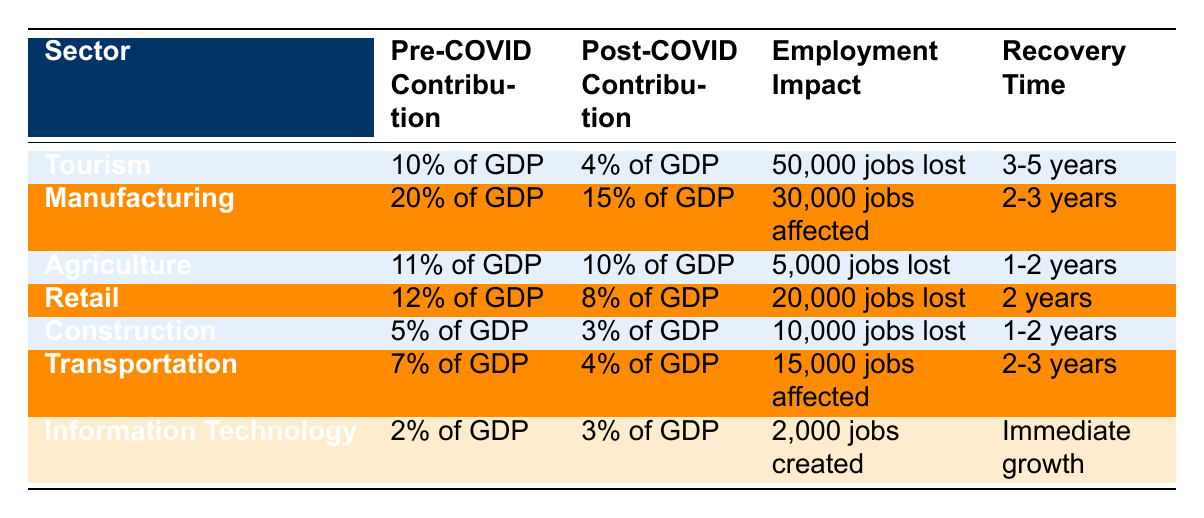What is the post-COVID contribution of the retail sector to GDP? The post-COVID contribution of the retail sector is found in the table, where it is listed as 8% of GDP.
Answer: 8% of GDP How many jobs were lost in the tourism sector due to COVID-19? The table specifies that the tourism sector experienced a loss of 50,000 jobs as a result of COVID-19.
Answer: 50,000 jobs Which sector had the highest pre-COVID contribution to GDP? By examining the pre-COVID contributions, we see that manufacturing had the highest contribution at 20% of GDP.
Answer: 20% of GDP How many jobs were affected in the manufacturing sector? The table indicates that the manufacturing sector had 30,000 jobs affected post-COVID.
Answer: 30,000 jobs What is the recovery time for the agriculture sector? According to the table, the recovery time for the agriculture sector is 1-2 years.
Answer: 1-2 years What is the difference in GDP contribution for the transportation sector before and after COVID-19? The pre-COVID contribution was 7% of GDP, and post-COVID it is 4%. The difference is 7% - 4% = 3%.
Answer: 3% Which sector has immediate growth after COVID-19? The table highlights that the information technology sector is experiencing immediate growth after COVID-19.
Answer: Information Technology What is the average employment impact of the sectors listed in the table? To find the average, first, we sum the absolute values of jobs lost or affected: 50,000 + 30,000 + 5,000 + 20,000 + 10,000 + 15,000 - 2,000 (created) = 128,000. Then, we divide by the number of sectors (7), giving us an average of approximately 18,285.71.
Answer: Approximately 18,286 Did the construction sector experience a net job creation or loss? The construction sector shows a loss of 10,000 jobs, which is reflected in the employment impact.
Answer: Loss What could be inferred about the recovery of the tourism sector compared to manufacturing? The tourism sector has a longer recovery time of 3-5 years compared to manufacturing's 2-3 years. This suggests tourism may take longer to rebound.
Answer: Tourism takes longer to recover 